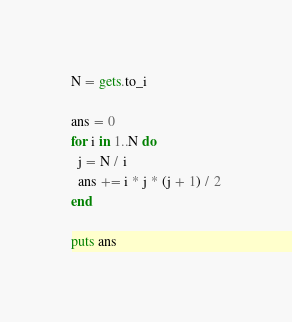<code> <loc_0><loc_0><loc_500><loc_500><_Ruby_>N = gets.to_i

ans = 0
for i in 1..N do
  j = N / i
  ans += i * j * (j + 1) / 2
end

puts ans</code> 